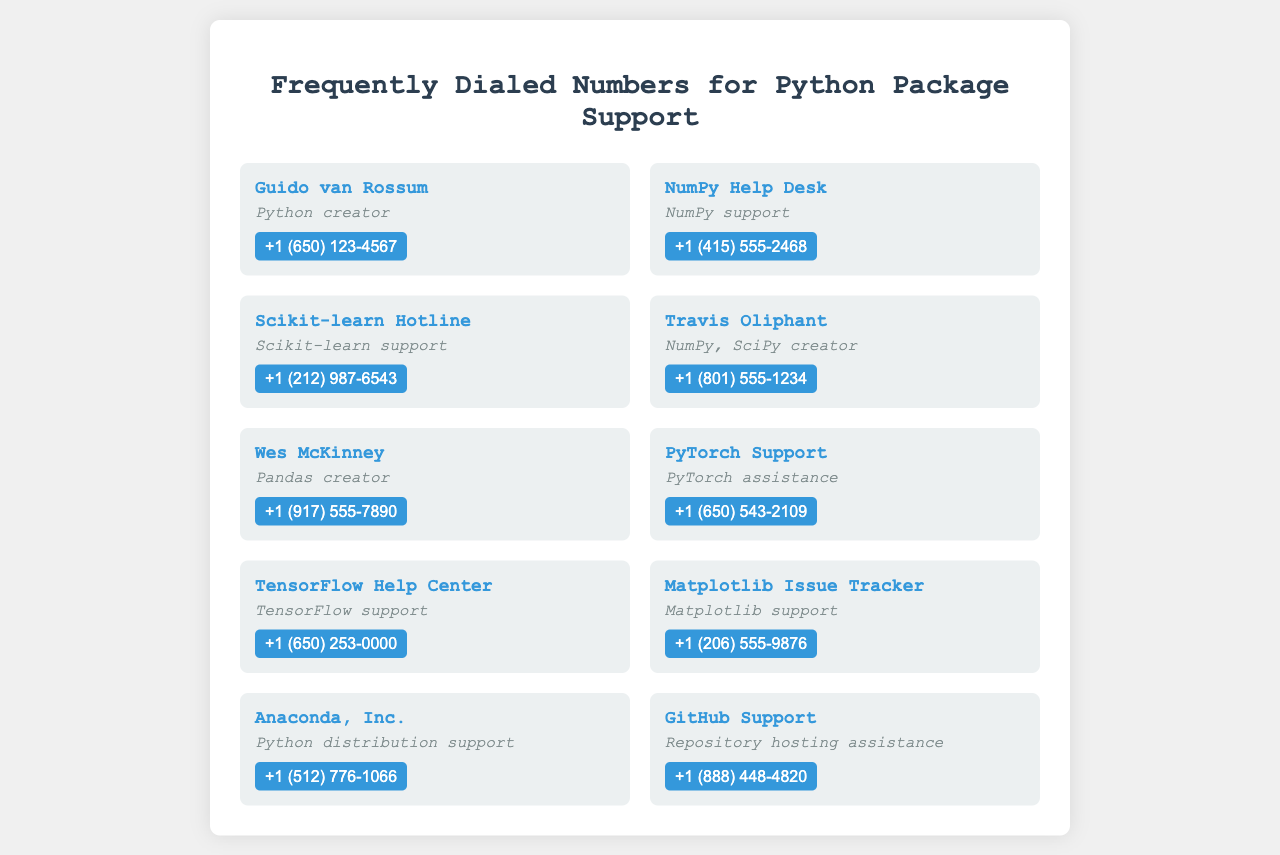What is the contact number for Guido van Rossum? The contact number for Guido van Rossum can be found in the document, identified by his name.
Answer: +1 (650) 123-4567 Who is the creator of Pandas? The document explicitly lists Wes McKinney as the creator of Pandas.
Answer: Wes McKinney What kind of support does the NumPy Help Desk provide? The document describes the role of the NumPy Help Desk as providing NumPy support.
Answer: NumPy support Which organization has the contact number +1 (512) 776-1066? The document reveals that this number belongs to Anaconda, Inc.
Answer: Anaconda, Inc How many contact cards are displayed in the document? The total contact cards can be counted from the entries listed, indicating the number of support contacts.
Answer: 10 What is the role of Travis Oliphant? The document mentions that Travis Oliphant is associated with both NumPy and SciPy as a creator.
Answer: NumPy, SciPy creator Which support center assists with TensorFlow? The document states that the TensorFlow Help Center is dedicated to assisting with TensorFlow support.
Answer: TensorFlow Help Center Name a support contact that assists with Scikit-learn. The Scikit-learn Hotline is specifically mentioned in the document as a support contact for Scikit-learn.
Answer: Scikit-learn Hotline 